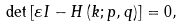Convert formula to latex. <formula><loc_0><loc_0><loc_500><loc_500>\det \left [ \varepsilon I - H \left ( k ; p , q \right ) \right ] = 0 ,</formula> 